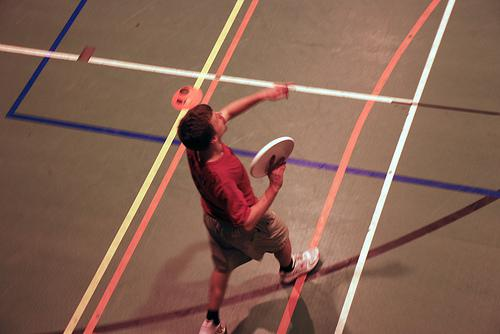Question: what is he doing?
Choices:
A. Swimming.
B. Sleeping.
C. Cooking.
D. Playing.
Answer with the letter. Answer: D Question: what is he playing?
Choices:
A. Golf.
B. Soccer.
C. Frisbee.
D. Tennis.
Answer with the letter. Answer: C Question: what is white?
Choices:
A. Her shirt.
B. Dog.
C. Horse.
D. The frisbee.
Answer with the letter. Answer: D Question: who is playing?
Choices:
A. The kids.
B. The musician.
C. The guy.
D. The boy.
Answer with the letter. Answer: C Question: where is the frisbee?
Choices:
A. In the air.
B. In his hand.
C. In the car.
D. At home.
Answer with the letter. Answer: B 